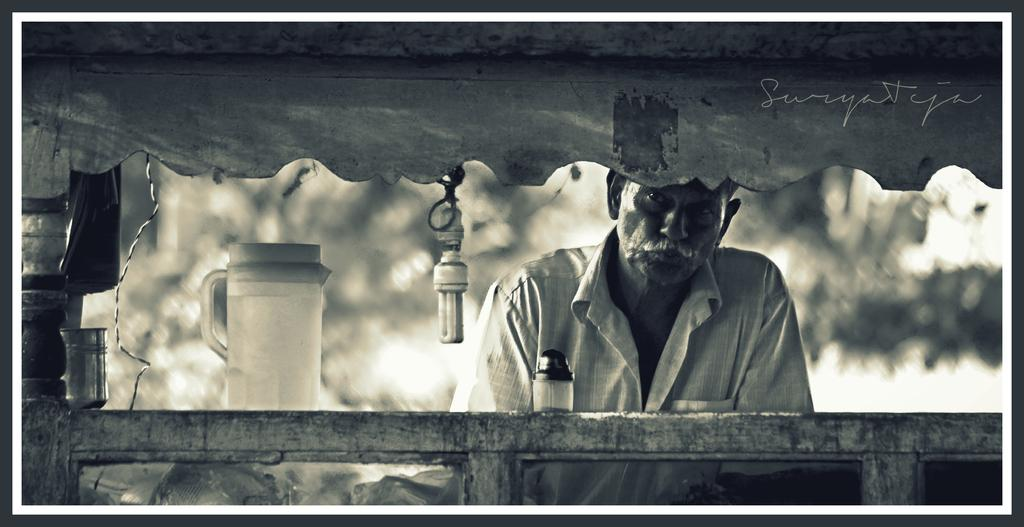What is the main subject of the image? There is a person in the image. What is in front of the person? There is a light, a jug, a glass, and a jar in front of the person. Can you describe the light in the image? There is a light in front of the person. What else is visible in the image? There is a wire visible in the image, and there is text on a wooden object. How would you describe the background of the image? The background of the image is blurred. What type of trousers is the person wearing in the image? There is no information about the person's trousers in the image, so we cannot determine what type they are wearing. What time does the show mentioned in the text on the wooden object start? There is no mention of a show or a time in the image, so we cannot answer this question. 